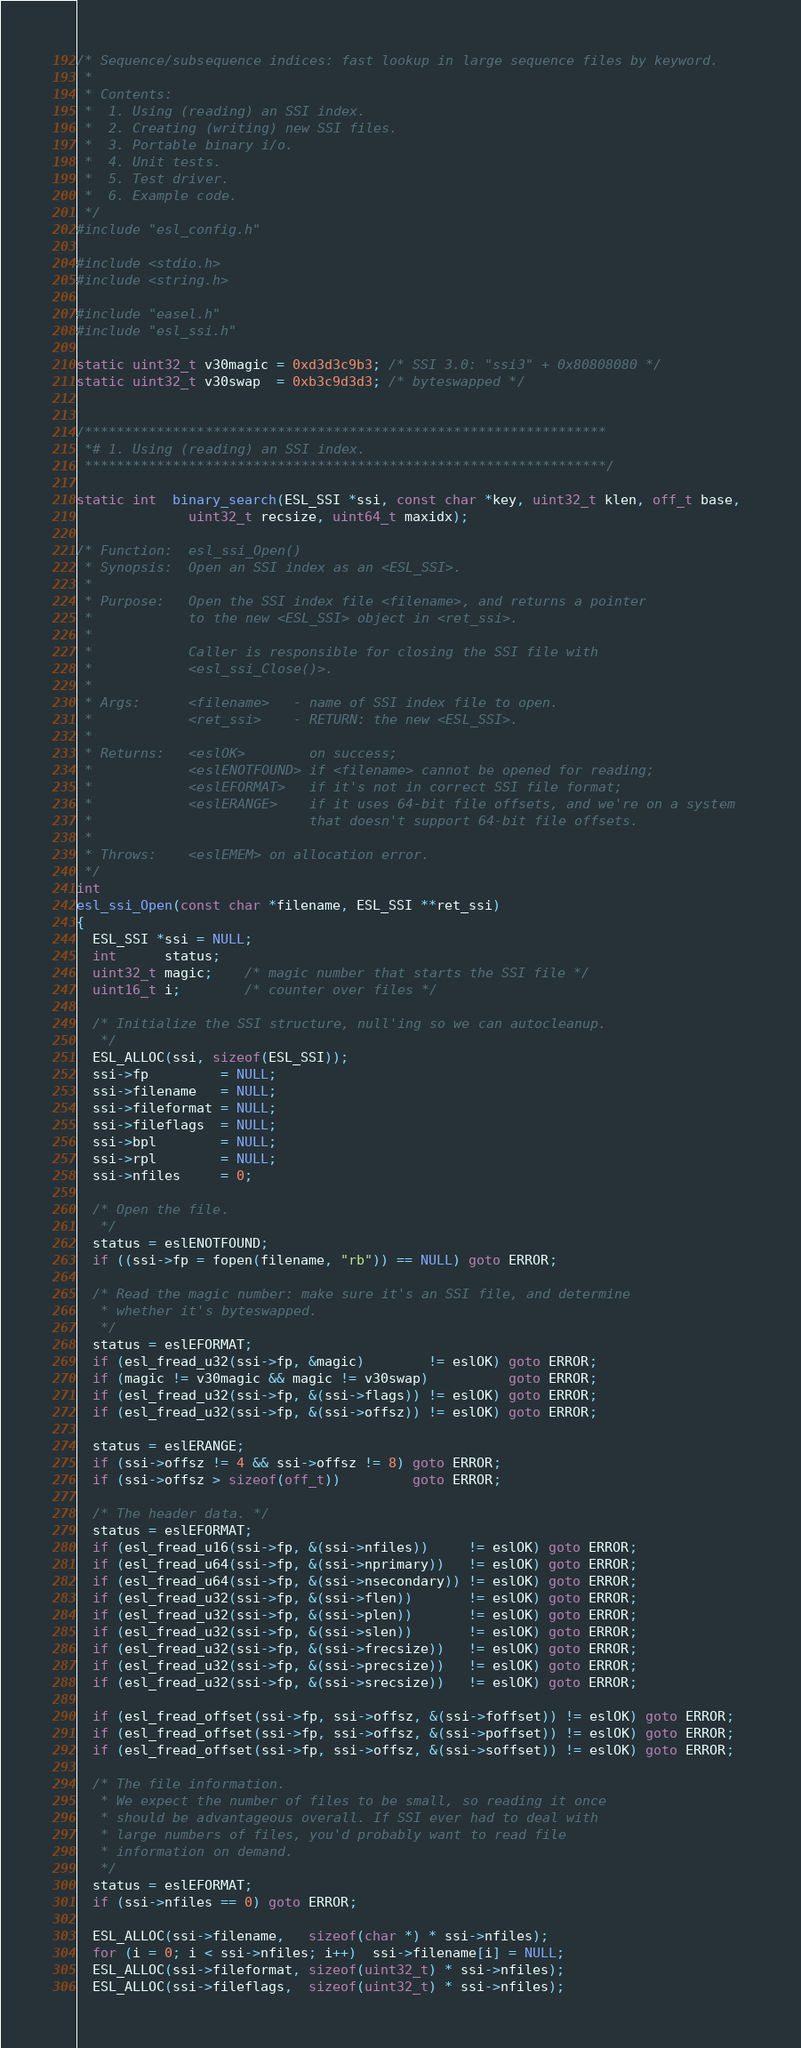Convert code to text. <code><loc_0><loc_0><loc_500><loc_500><_C_>/* Sequence/subsequence indices: fast lookup in large sequence files by keyword.
 *
 * Contents:
 *  1. Using (reading) an SSI index.
 *  2. Creating (writing) new SSI files.
 *  3. Portable binary i/o.
 *  4. Unit tests.
 *  5. Test driver.
 *  6. Example code.
 */
#include "esl_config.h"

#include <stdio.h>
#include <string.h>

#include "easel.h"
#include "esl_ssi.h"

static uint32_t v30magic = 0xd3d3c9b3; /* SSI 3.0: "ssi3" + 0x80808080 */
static uint32_t v30swap  = 0xb3c9d3d3; /* byteswapped */


/*****************************************************************
 *# 1. Using (reading) an SSI index.
 *****************************************************************/ 

static int  binary_search(ESL_SSI *ssi, const char *key, uint32_t klen, off_t base, 
			  uint32_t recsize, uint64_t maxidx);

/* Function:  esl_ssi_Open()
 * Synopsis:  Open an SSI index as an <ESL_SSI>.
 *
 * Purpose:   Open the SSI index file <filename>, and returns a pointer
 *            to the new <ESL_SSI> object in <ret_ssi>.
 *            
 *            Caller is responsible for closing the SSI file with
 *            <esl_ssi_Close()>.
 *
 * Args:      <filename>   - name of SSI index file to open.       
 *            <ret_ssi>    - RETURN: the new <ESL_SSI>.
 *                        
 * Returns:   <eslOK>        on success;
 *            <eslENOTFOUND> if <filename> cannot be opened for reading;
 *            <eslEFORMAT>   if it's not in correct SSI file format;
 *            <eslERANGE>    if it uses 64-bit file offsets, and we're on a system
 *                           that doesn't support 64-bit file offsets.
 *            
 * Throws:    <eslEMEM> on allocation error.
 */
int
esl_ssi_Open(const char *filename, ESL_SSI **ret_ssi)
{
  ESL_SSI *ssi = NULL;
  int      status;
  uint32_t magic;	/* magic number that starts the SSI file */
  uint16_t i;		/* counter over files */

  /* Initialize the SSI structure, null'ing so we can autocleanup.
   */
  ESL_ALLOC(ssi, sizeof(ESL_SSI));
  ssi->fp         = NULL;
  ssi->filename   = NULL;
  ssi->fileformat = NULL;
  ssi->fileflags  = NULL;
  ssi->bpl        = NULL;
  ssi->rpl        = NULL;
  ssi->nfiles     = 0;          

  /* Open the file.
   */
  status = eslENOTFOUND; 
  if ((ssi->fp = fopen(filename, "rb")) == NULL) goto ERROR; 

  /* Read the magic number: make sure it's an SSI file, and determine
   * whether it's byteswapped.
   */
  status = eslEFORMAT;
  if (esl_fread_u32(ssi->fp, &magic)        != eslOK) goto ERROR;
  if (magic != v30magic && magic != v30swap)          goto ERROR;
  if (esl_fread_u32(ssi->fp, &(ssi->flags)) != eslOK) goto ERROR;
  if (esl_fread_u32(ssi->fp, &(ssi->offsz)) != eslOK) goto ERROR;

  status = eslERANGE;
  if (ssi->offsz != 4 && ssi->offsz != 8) goto ERROR;
  if (ssi->offsz > sizeof(off_t))         goto ERROR;

  /* The header data. */
  status = eslEFORMAT;
  if (esl_fread_u16(ssi->fp, &(ssi->nfiles))     != eslOK) goto ERROR;
  if (esl_fread_u64(ssi->fp, &(ssi->nprimary))   != eslOK) goto ERROR;
  if (esl_fread_u64(ssi->fp, &(ssi->nsecondary)) != eslOK) goto ERROR;
  if (esl_fread_u32(ssi->fp, &(ssi->flen))       != eslOK) goto ERROR;
  if (esl_fread_u32(ssi->fp, &(ssi->plen))       != eslOK) goto ERROR;
  if (esl_fread_u32(ssi->fp, &(ssi->slen))       != eslOK) goto ERROR;
  if (esl_fread_u32(ssi->fp, &(ssi->frecsize))   != eslOK) goto ERROR;
  if (esl_fread_u32(ssi->fp, &(ssi->precsize))   != eslOK) goto ERROR;
  if (esl_fread_u32(ssi->fp, &(ssi->srecsize))   != eslOK) goto ERROR;
  
  if (esl_fread_offset(ssi->fp, ssi->offsz, &(ssi->foffset)) != eslOK) goto ERROR;
  if (esl_fread_offset(ssi->fp, ssi->offsz, &(ssi->poffset)) != eslOK) goto ERROR;
  if (esl_fread_offset(ssi->fp, ssi->offsz, &(ssi->soffset)) != eslOK) goto ERROR;

  /* The file information.
   * We expect the number of files to be small, so reading it once
   * should be advantageous overall. If SSI ever had to deal with
   * large numbers of files, you'd probably want to read file
   * information on demand.
   */
  status = eslEFORMAT;
  if (ssi->nfiles == 0) goto ERROR;

  ESL_ALLOC(ssi->filename,   sizeof(char *) * ssi->nfiles);
  for (i = 0; i < ssi->nfiles; i++)  ssi->filename[i] = NULL; 
  ESL_ALLOC(ssi->fileformat, sizeof(uint32_t) * ssi->nfiles);
  ESL_ALLOC(ssi->fileflags,  sizeof(uint32_t) * ssi->nfiles);</code> 